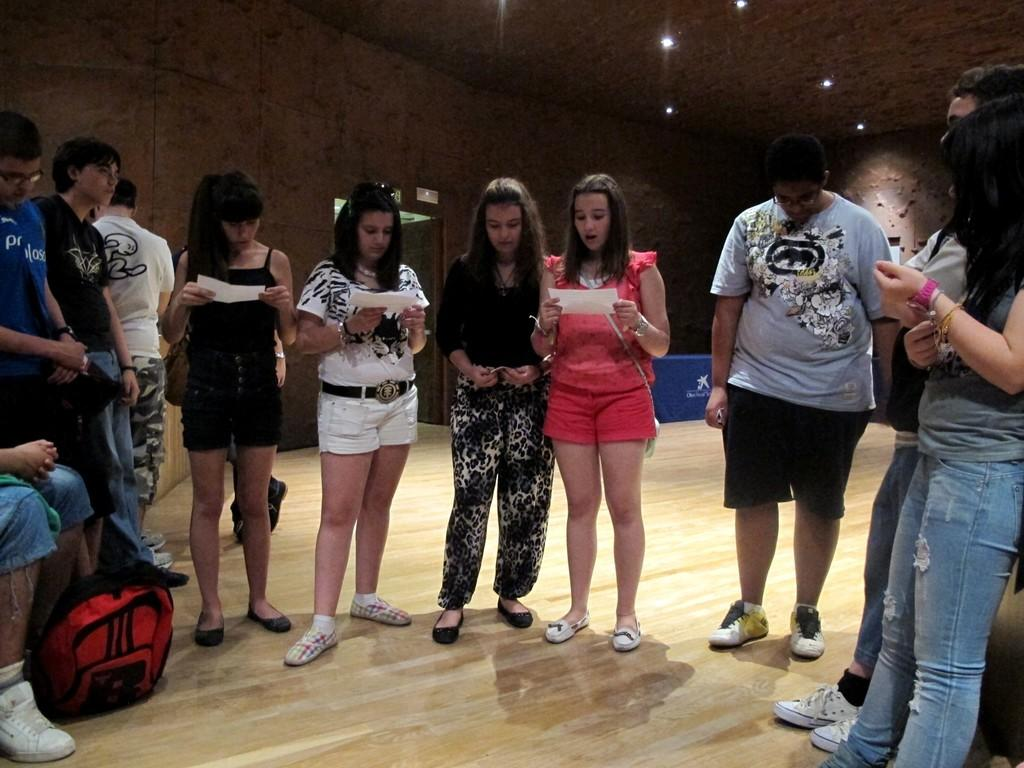Who or what can be seen in the image? There are people in the image. What can be seen under the people's feet in the image? The ground is visible in the image with some objects. What architectural feature is present in the image? There is a wall with a door in the image. What is on top of the wall in the image? There are lights on the roof in the image. What type of muscle is being exercised by the people in the image? There is no indication of any exercise or muscle activity in the image; it simply shows people in a setting with a wall, door, and lights. 